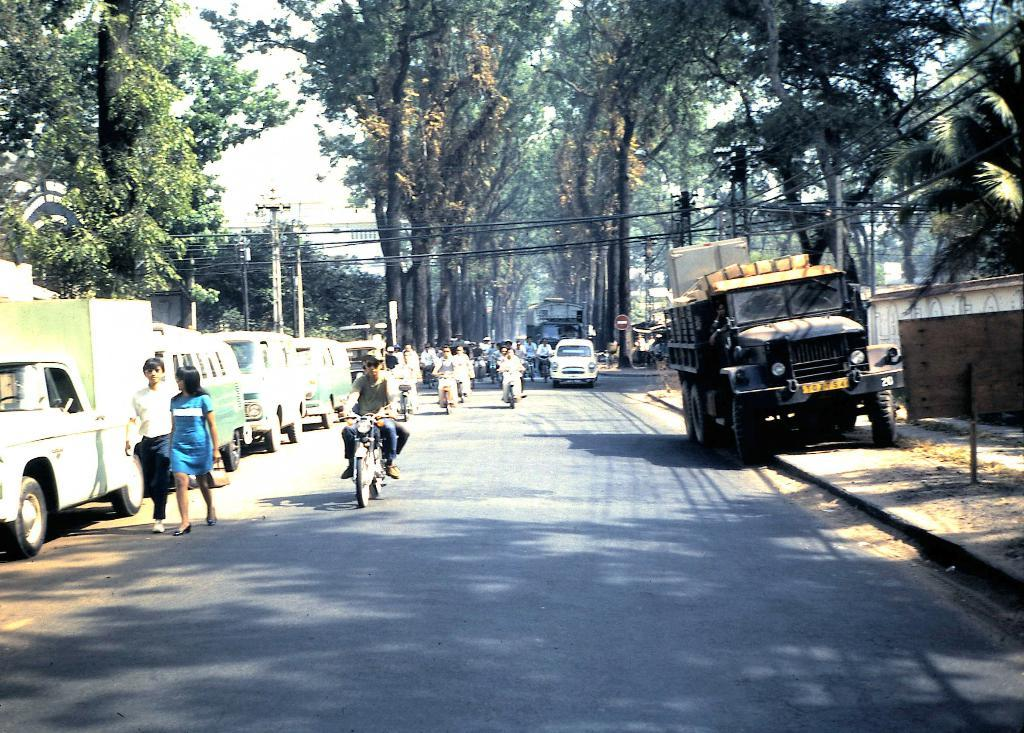What is the main feature of the image? There is a road in the image. What is happening on the road? Vehicles are moving on the road. Are there any vehicles not in motion in the image? Yes, there are parked vehicles beside the road. What can be seen behind the vehicles? Trees are visible behind the vehicles. What infrastructure is present in the image? Current poles are present in the image. What type of cannon can be seen firing in the image? There is no cannon present in the image. What scientific experiment is being conducted in the image? There is no scientific experiment depicted in the image. Is there any magical element visible in the image? There is no magical element present in the image. 